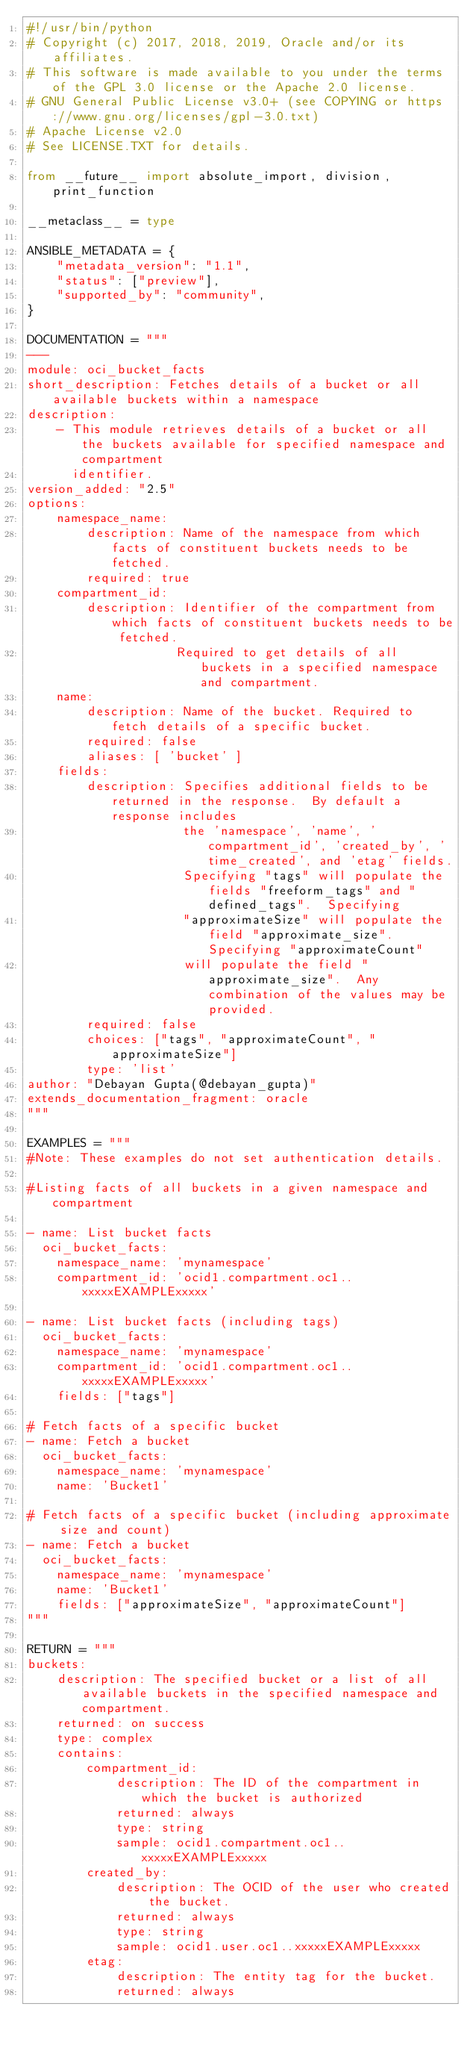<code> <loc_0><loc_0><loc_500><loc_500><_Python_>#!/usr/bin/python
# Copyright (c) 2017, 2018, 2019, Oracle and/or its affiliates.
# This software is made available to you under the terms of the GPL 3.0 license or the Apache 2.0 license.
# GNU General Public License v3.0+ (see COPYING or https://www.gnu.org/licenses/gpl-3.0.txt)
# Apache License v2.0
# See LICENSE.TXT for details.

from __future__ import absolute_import, division, print_function

__metaclass__ = type

ANSIBLE_METADATA = {
    "metadata_version": "1.1",
    "status": ["preview"],
    "supported_by": "community",
}

DOCUMENTATION = """
---
module: oci_bucket_facts
short_description: Fetches details of a bucket or all available buckets within a namespace
description:
    - This module retrieves details of a bucket or all the buckets available for specified namespace and compartment
      identifier.
version_added: "2.5"
options:
    namespace_name:
        description: Name of the namespace from which facts of constituent buckets needs to be fetched.
        required: true
    compartment_id:
        description: Identifier of the compartment from which facts of constituent buckets needs to be fetched.
                    Required to get details of all buckets in a specified namespace and compartment.
    name:
        description: Name of the bucket. Required to fetch details of a specific bucket.
        required: false
        aliases: [ 'bucket' ]
    fields:
        description: Specifies additional fields to be returned in the response.  By default a response includes
                     the 'namespace', 'name', 'compartment_id', 'created_by', 'time_created', and 'etag' fields.
                     Specifying "tags" will populate the fields "freeform_tags" and "defined_tags".  Specifying
                     "approximateSize" will populate the field "approximate_size".  Specifying "approximateCount"
                     will populate the field "approximate_size".  Any combination of the values may be provided.
        required: false
        choices: ["tags", "approximateCount", "approximateSize"]
        type: 'list'
author: "Debayan Gupta(@debayan_gupta)"
extends_documentation_fragment: oracle
"""

EXAMPLES = """
#Note: These examples do not set authentication details.

#Listing facts of all buckets in a given namespace and compartment

- name: List bucket facts
  oci_bucket_facts:
    namespace_name: 'mynamespace'
    compartment_id: 'ocid1.compartment.oc1..xxxxxEXAMPLExxxxx'

- name: List bucket facts (including tags)
  oci_bucket_facts:
    namespace_name: 'mynamespace'
    compartment_id: 'ocid1.compartment.oc1..xxxxxEXAMPLExxxxx'
    fields: ["tags"]

# Fetch facts of a specific bucket
- name: Fetch a bucket
  oci_bucket_facts:
    namespace_name: 'mynamespace'
    name: 'Bucket1'

# Fetch facts of a specific bucket (including approximate size and count)
- name: Fetch a bucket
  oci_bucket_facts:
    namespace_name: 'mynamespace'
    name: 'Bucket1'
    fields: ["approximateSize", "approximateCount"]
"""

RETURN = """
buckets:
    description: The specified bucket or a list of all available buckets in the specified namespace and compartment.
    returned: on success
    type: complex
    contains:
        compartment_id:
            description: The ID of the compartment in which the bucket is authorized
            returned: always
            type: string
            sample: ocid1.compartment.oc1..xxxxxEXAMPLExxxxx
        created_by:
            description: The OCID of the user who created the bucket.
            returned: always
            type: string
            sample: ocid1.user.oc1..xxxxxEXAMPLExxxxx
        etag:
            description: The entity tag for the bucket.
            returned: always</code> 